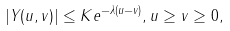<formula> <loc_0><loc_0><loc_500><loc_500>| Y ( u , v ) | \leq K e ^ { - \lambda ( u - v ) } , u \geq v \geq 0 ,</formula> 